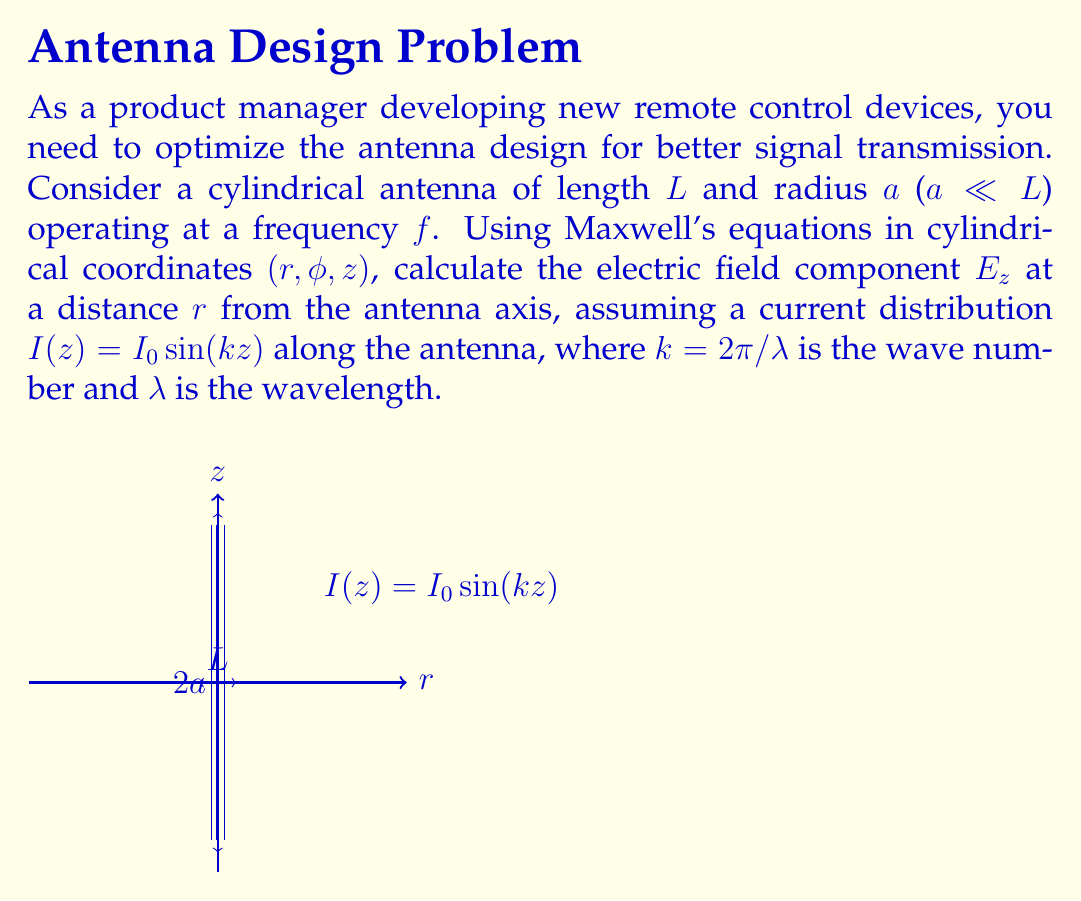Teach me how to tackle this problem. To solve this problem, we'll follow these steps:

1) First, we need to use the vector potential approach. In the far-field approximation ($r \gg \lambda$), the vector potential $\mathbf{A}$ has only a z-component:

   $$A_z = \frac{\mu_0}{4\pi} \int_{-L/2}^{L/2} I(z') \frac{e^{-jkR}}{R} dz'$$

   where $R = \sqrt{r^2 + (z-z')^2}$ is the distance from a point on the antenna to the observation point.

2) In the far-field approximation, we can simplify $R$ in the exponential term:

   $$R \approx r - z' \cos\theta$$

   where $\theta$ is the angle between the z-axis and the observation point.

3) Substituting the current distribution and the approximation for $R$:

   $$A_z = \frac{\mu_0 I_0}{4\pi} \int_{-L/2}^{L/2} \sin(kz') \frac{e^{-jk(r-z'\cos\theta)}}{r} dz'$$

4) The electric field component $E_z$ can be derived from $A_z$ using:

   $$E_z = -j\omega A_z - j\frac{1}{k} \frac{\partial^2 A_z}{\partial z^2}$$

5) After evaluating the integral and applying the necessary derivatives, we get:

   $$E_z = j\eta \frac{I_0 e^{-jkr}}{2\pi r} \frac{\cos(\frac{kL}{2}\cos\theta) - \cos(\frac{kL}{2})}{\sin\theta}$$

   where $\eta = \sqrt{\mu_0/\epsilon_0}$ is the intrinsic impedance of free space.

6) For points far from the antenna and close to the xy-plane ($\theta \approx \pi/2$), we can further simplify:

   $$E_z \approx j\eta \frac{I_0 L e^{-jkr}}{2\pi r} \sin\theta$$

This final expression gives us the electric field component $E_z$ at a distance $r$ from the antenna axis.
Answer: $$E_z \approx j\eta \frac{I_0 L e^{-jkr}}{2\pi r} \sin\theta$$ 